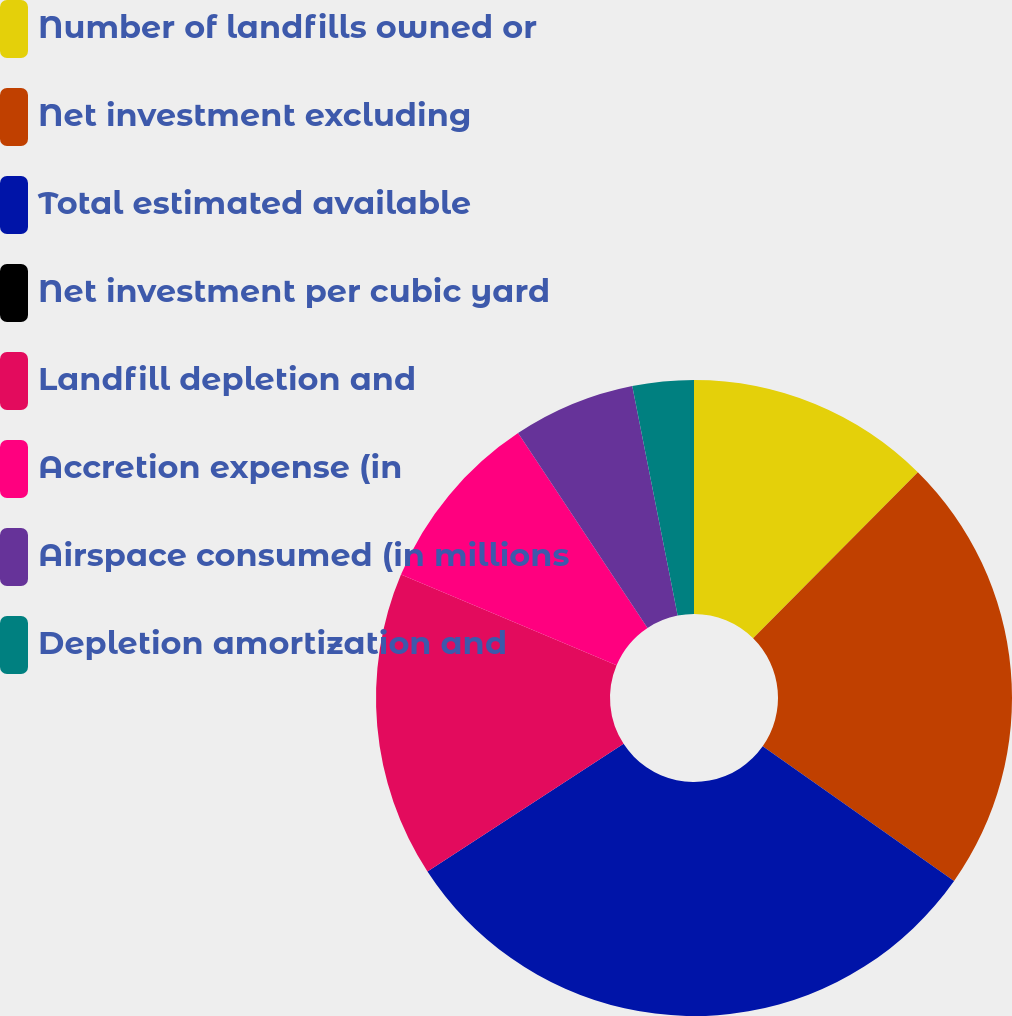Convert chart. <chart><loc_0><loc_0><loc_500><loc_500><pie_chart><fcel>Number of landfills owned or<fcel>Net investment excluding<fcel>Total estimated available<fcel>Net investment per cubic yard<fcel>Landfill depletion and<fcel>Accretion expense (in<fcel>Airspace consumed (in millions<fcel>Depletion amortization and<nl><fcel>12.43%<fcel>22.33%<fcel>31.06%<fcel>0.0%<fcel>15.53%<fcel>9.32%<fcel>6.22%<fcel>3.11%<nl></chart> 